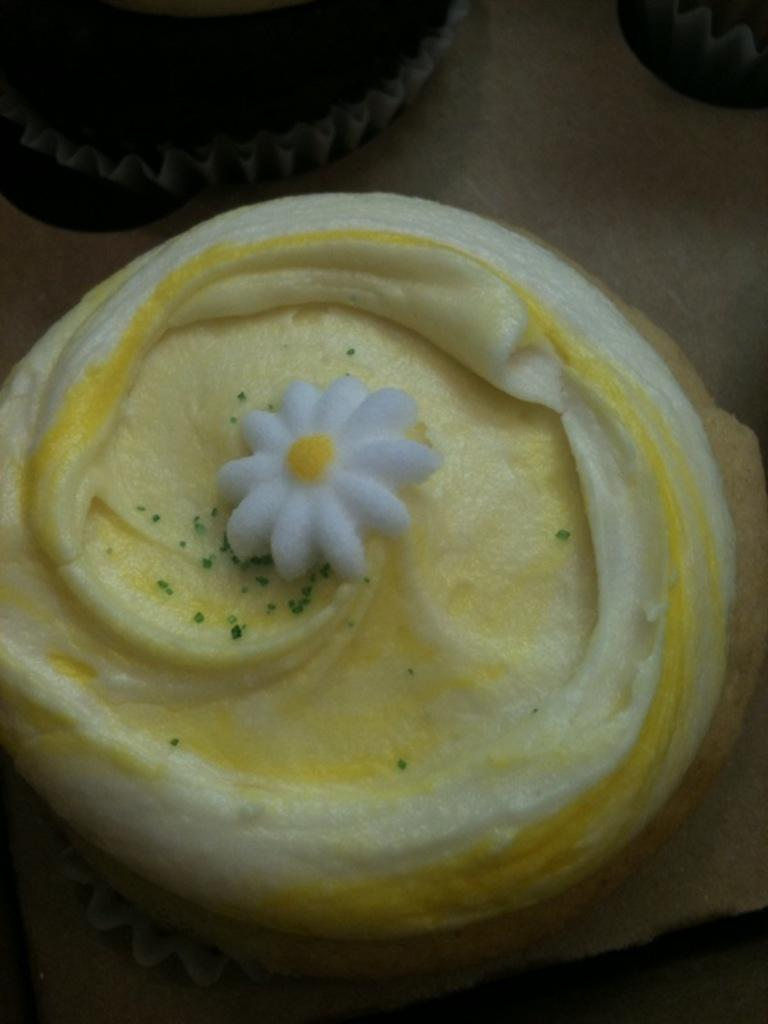What type of dessert can be seen in the image? There are cupcakes in the image. What is on top of the cupcakes? The cupcakes have cream on them. Where are the cupcakes located? The cupcakes are placed on a platform. What type of bears can be seen interacting with the cupcakes in the image? There are no bears present in the image; it only features cupcakes with cream on them. 